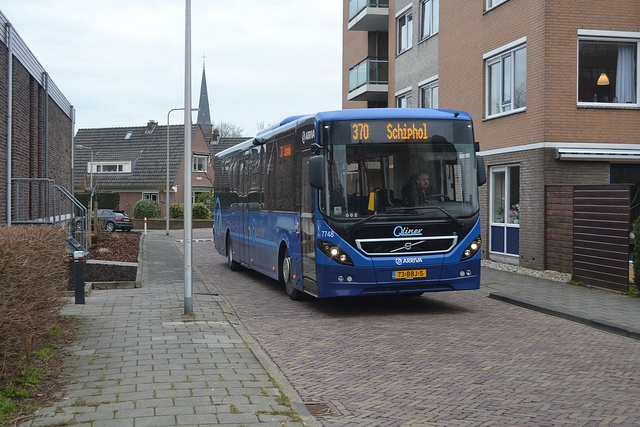Describe the objects in this image and their specific colors. I can see bus in white, black, gray, navy, and darkblue tones, car in white, gray, and black tones, people in white, black, and gray tones, vase in white, gray, darkblue, and black tones, and vase in white, black, and purple tones in this image. 